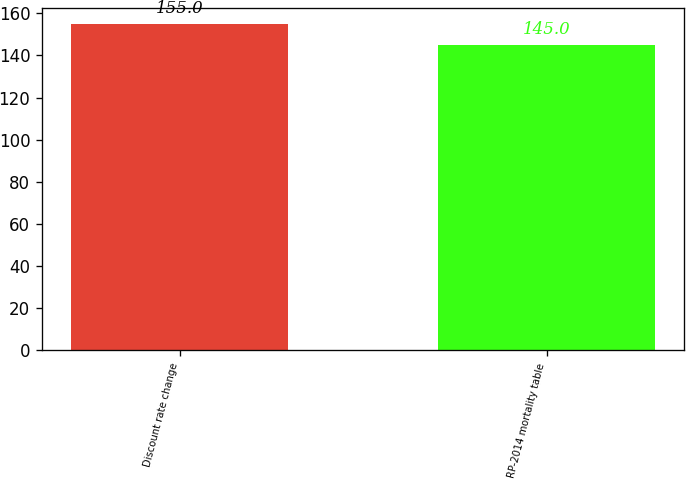<chart> <loc_0><loc_0><loc_500><loc_500><bar_chart><fcel>Discount rate change<fcel>RP-2014 mortality table<nl><fcel>155<fcel>145<nl></chart> 